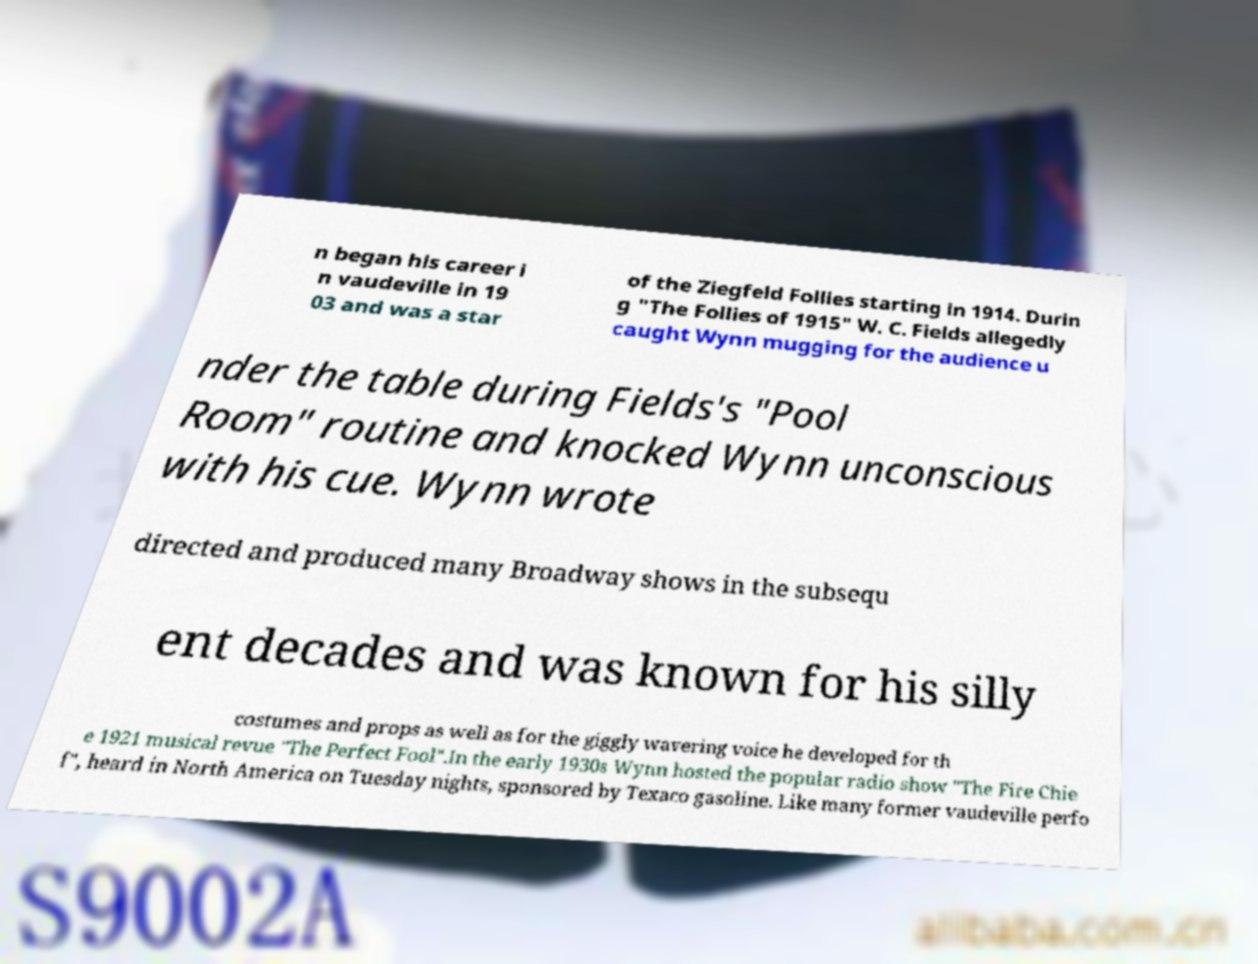What messages or text are displayed in this image? I need them in a readable, typed format. n began his career i n vaudeville in 19 03 and was a star of the Ziegfeld Follies starting in 1914. Durin g "The Follies of 1915" W. C. Fields allegedly caught Wynn mugging for the audience u nder the table during Fields's "Pool Room" routine and knocked Wynn unconscious with his cue. Wynn wrote directed and produced many Broadway shows in the subsequ ent decades and was known for his silly costumes and props as well as for the giggly wavering voice he developed for th e 1921 musical revue "The Perfect Fool".In the early 1930s Wynn hosted the popular radio show "The Fire Chie f", heard in North America on Tuesday nights, sponsored by Texaco gasoline. Like many former vaudeville perfo 